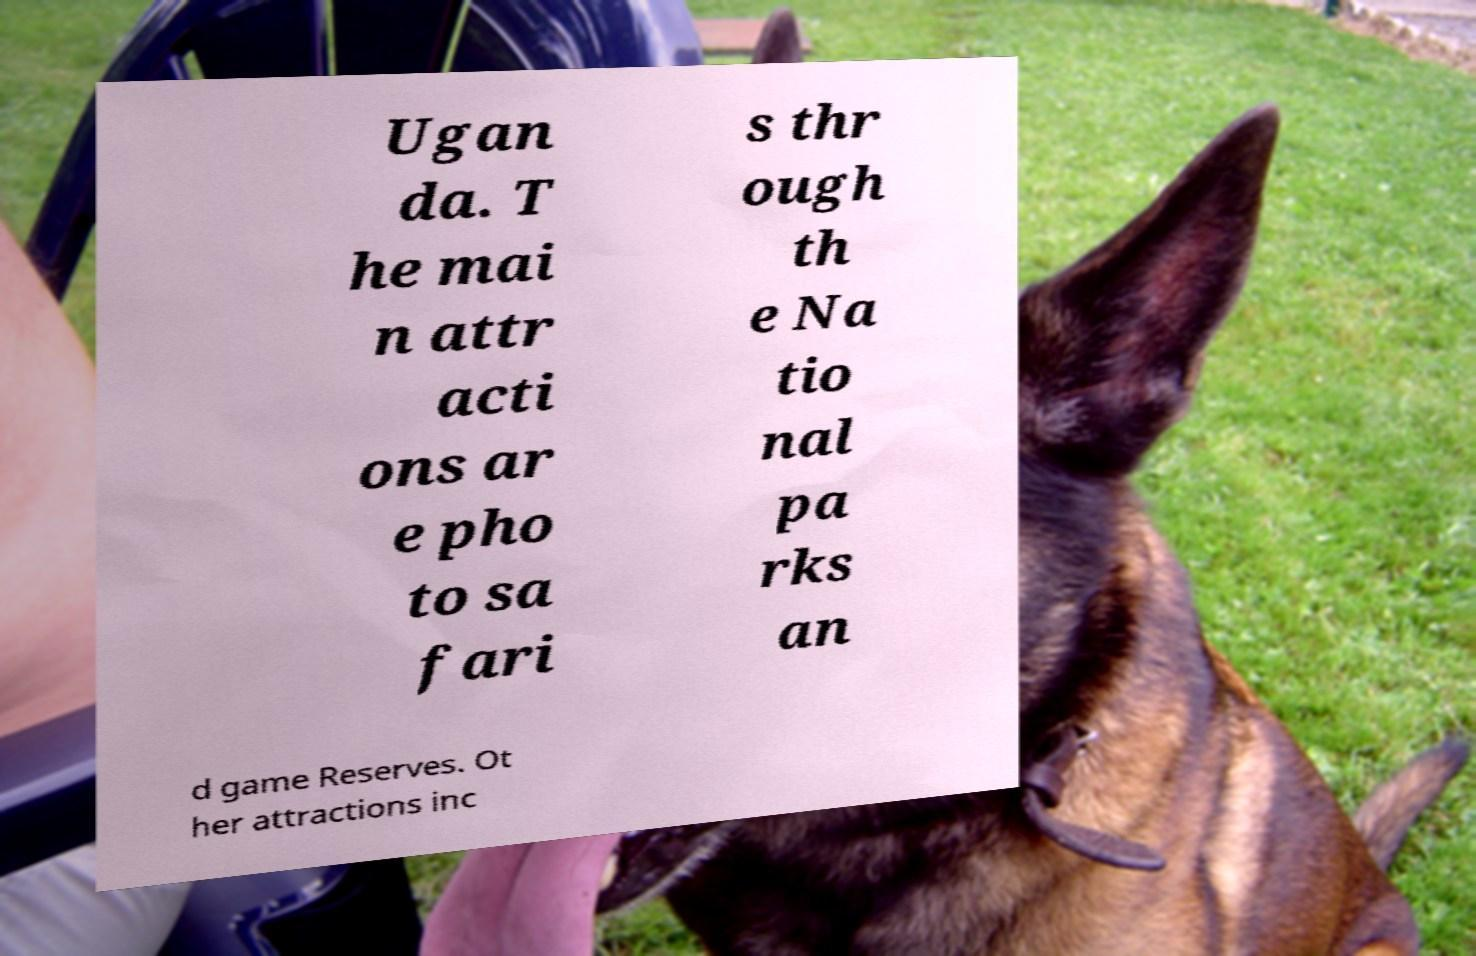Can you read and provide the text displayed in the image?This photo seems to have some interesting text. Can you extract and type it out for me? Ugan da. T he mai n attr acti ons ar e pho to sa fari s thr ough th e Na tio nal pa rks an d game Reserves. Ot her attractions inc 